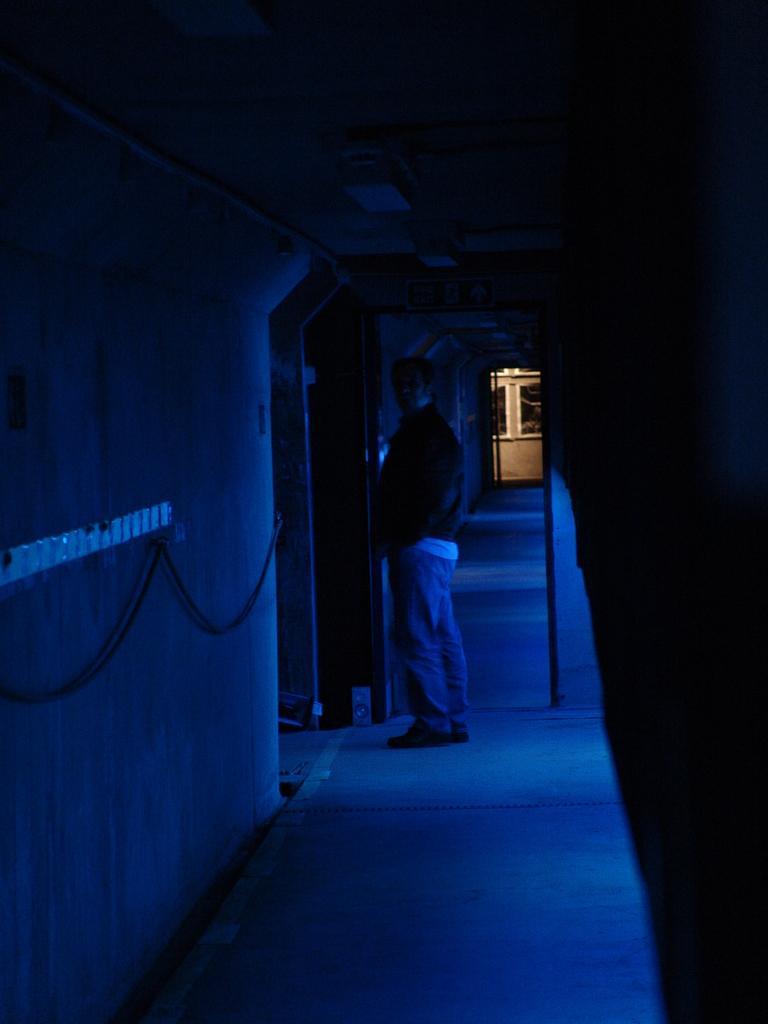Please provide a concise description of this image. Here we can see a man standing on the floor. There is a board, ceiling, and wall. 